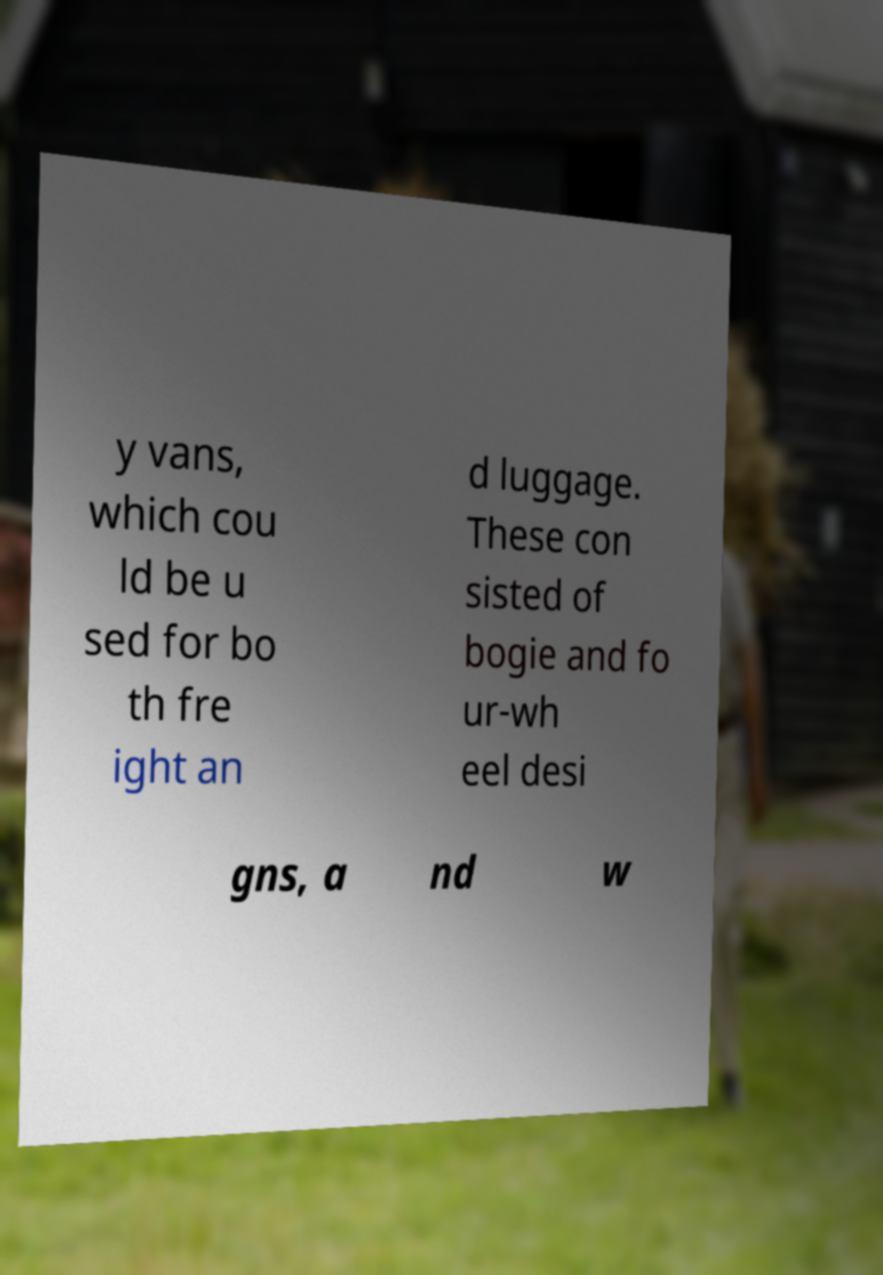There's text embedded in this image that I need extracted. Can you transcribe it verbatim? y vans, which cou ld be u sed for bo th fre ight an d luggage. These con sisted of bogie and fo ur-wh eel desi gns, a nd w 